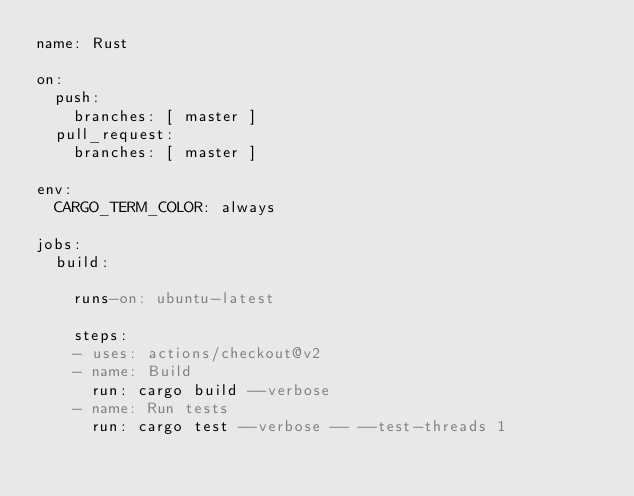<code> <loc_0><loc_0><loc_500><loc_500><_YAML_>name: Rust

on:
  push:
    branches: [ master ]
  pull_request:
    branches: [ master ]

env:
  CARGO_TERM_COLOR: always

jobs:
  build:

    runs-on: ubuntu-latest

    steps:
    - uses: actions/checkout@v2
    - name: Build
      run: cargo build --verbose
    - name: Run tests
      run: cargo test --verbose -- --test-threads 1
</code> 